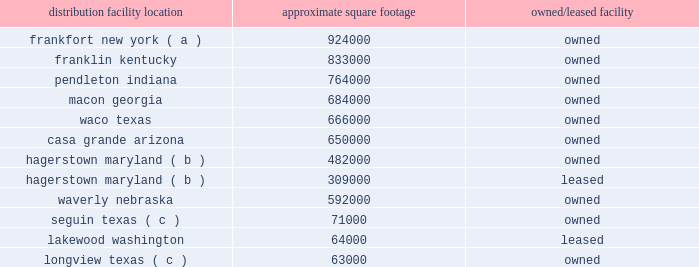The following is a list of distribution locations including the approximate square footage and if the location is leased or owned: .
Longview , texas ( c ) 63000 owned ( a ) the frankfort , new york , distribution center began receiving merchandise in fourth quarter of fiscal 2018 , and is expected to begin shipping merchandise to stores in the first quarter of fiscal 2019 .
( b ) the leased distribution center in hagerstown is treated as an extension of the existing owned hagerstown location and is not considered a separate distribution center .
( c ) this is a mixing center designed to process certain high-volume bulk products .
The company 2019s store support center occupies approximately 260000 square feet of owned building space in brentwood , tennessee , and the company 2019s merchandising innovation center occupies approximately 32000 square feet of leased building space in nashville , tennessee .
The company also leases approximately 8000 square feet of building space for the petsense corporate headquarters , located in scottsdale , arizona .
Item 3 .
Legal proceedings the company is involved in various litigation matters arising in the ordinary course of business .
The company believes that any estimated loss related to such matters has been adequately provided for in accrued liabilities to the extent probable and reasonably estimable .
Accordingly , the company currently expects these matters will be resolved without material adverse effect on its consolidated financial position , results of operations or cash flows .
Item 4 .
Mine safety disclosures not applicable. .
What is the total texas facilities square footage? 
Computations: ((71000 + 63000) + 666000)
Answer: 800000.0. 